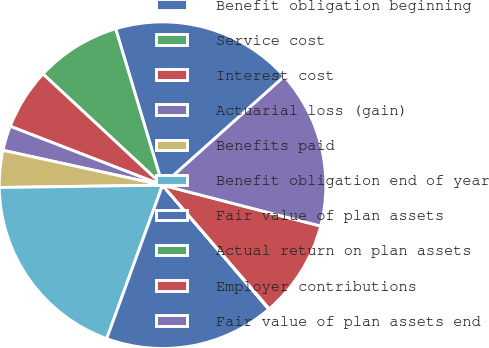Convert chart to OTSL. <chart><loc_0><loc_0><loc_500><loc_500><pie_chart><fcel>Benefit obligation beginning<fcel>Service cost<fcel>Interest cost<fcel>Actuarial loss (gain)<fcel>Benefits paid<fcel>Benefit obligation end of year<fcel>Fair value of plan assets<fcel>Actual return on plan assets<fcel>Employer contributions<fcel>Fair value of plan assets end<nl><fcel>18.03%<fcel>8.44%<fcel>6.05%<fcel>2.45%<fcel>3.65%<fcel>19.22%<fcel>16.83%<fcel>0.06%<fcel>9.64%<fcel>15.63%<nl></chart> 